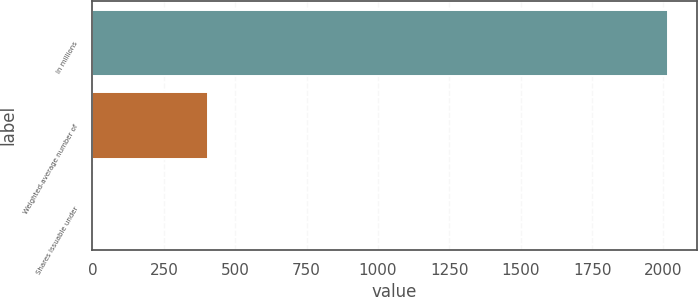Convert chart to OTSL. <chart><loc_0><loc_0><loc_500><loc_500><bar_chart><fcel>In millions<fcel>Weighted-average number of<fcel>Shares issuable under<nl><fcel>2015<fcel>403.8<fcel>1<nl></chart> 